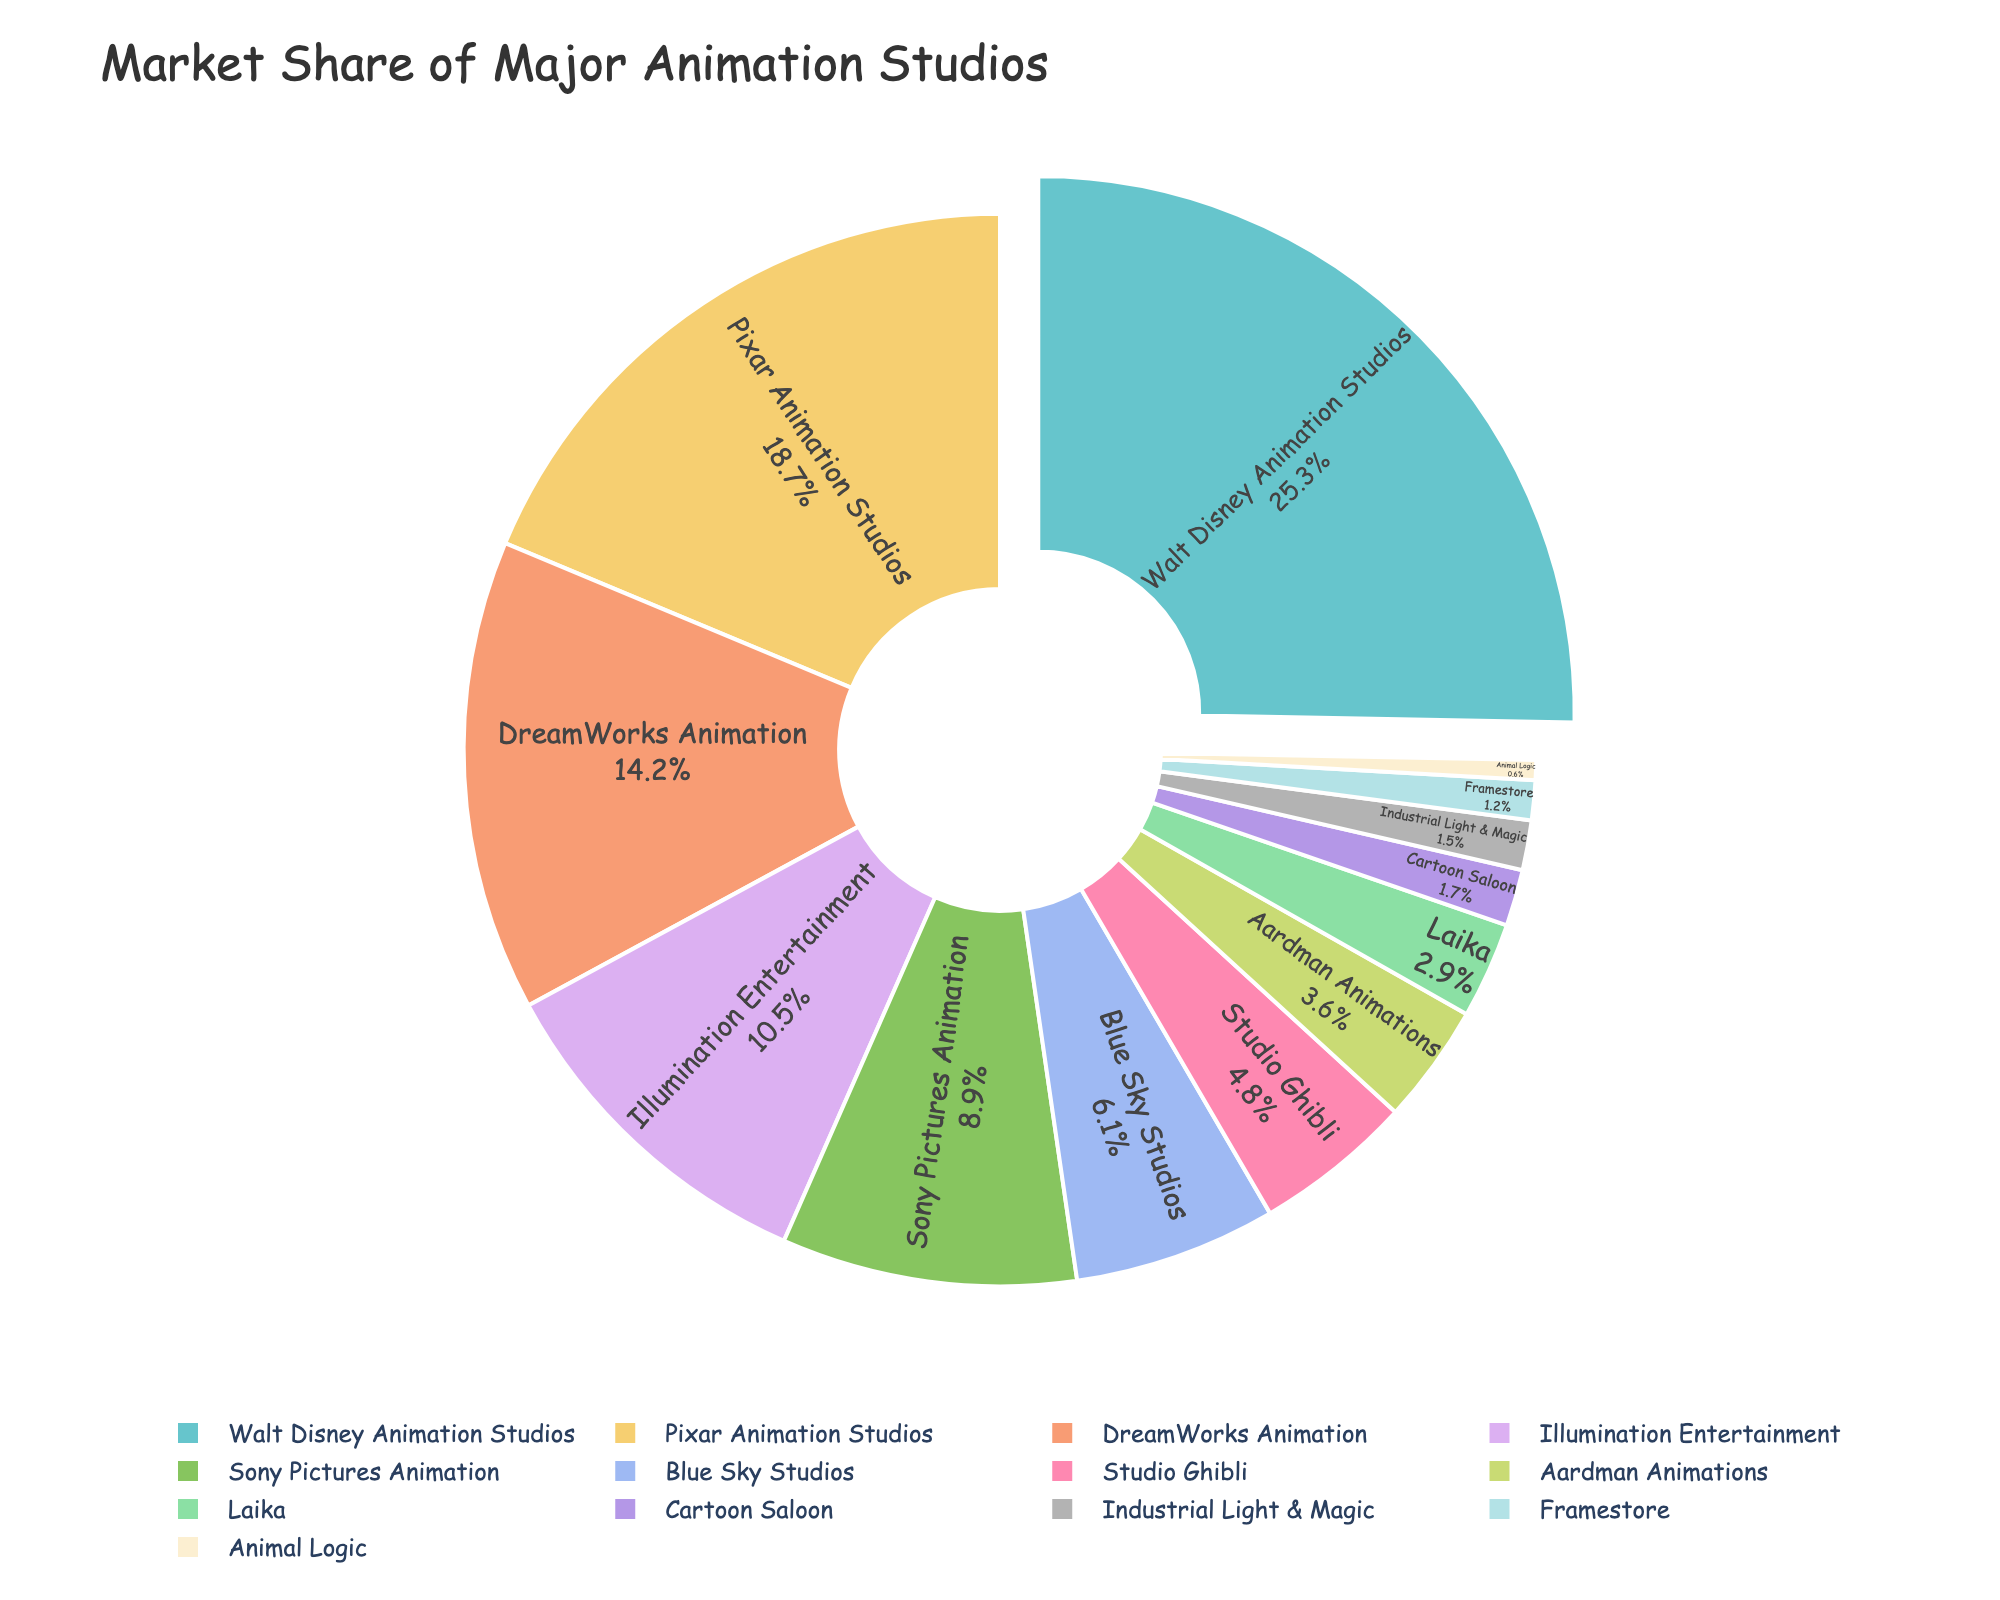What percentage of the market is held by Walt Disney Animation Studios? According to the pie chart, Walt Disney Animation Studios holds 25.3% of the global market share.
Answer: 25.3% What is the combined market share of DreamWorks Animation and Pixar Animation Studios? DreamWorks Animation holds 14.2% and Pixar Animation Studios holds 18.7%. To find the combined market share, add these two values: 14.2% + 18.7% = 32.9%.
Answer: 32.9% Which studio has a larger market share, Sony Pictures Animation or Blue Sky Studios? According to the pie chart, Sony Pictures Animation has 8.9% while Blue Sky Studios has 6.1%. Therefore, Sony Pictures Animation has a larger market share.
Answer: Sony Pictures Animation What is the market share difference between Illumination Entertainment and Studio Ghibli? Illumination Entertainment has a market share of 10.5%, while Studio Ghibli has 4.8%. Subtract the smaller share from the larger share: 10.5% - 4.8% = 5.7%.
Answer: 5.7% Which studio has the smallest market share and what is its value? The pie chart shows that Animal Logic has the smallest market share with 0.6%.
Answer: Animal Logic, 0.6% What is the total market share of the studios with a market share less than 5%? Studios with less than 5% market share are Studio Ghibli (4.8%), Aardman Animations (3.6%), Laika (2.9%), Cartoon Saloon (1.7%), Industrial Light & Magic (1.5%), Framestore (1.2%), and Animal Logic (0.6%). Adding these values: 4.8% + 3.6% + 2.9% + 1.7% + 1.5% + 1.2% + 0.6% = 16.3%.
Answer: 16.3% How many animation studios have a market share greater than or equal to 10%? The studios with a market share greater than or equal to 10% are Walt Disney Animation Studios (25.3%), Pixar Animation Studios (18.7%), and Illumination Entertainment (10.5%). There are three such studios.
Answer: 3 Which studio has the second largest market share and what is its value? According to the pie chart, Pixar Animation Studios has the second largest market share with 18.7%.
Answer: Pixar Animation Studios, 18.7% What's the combined market share of the bottom three studios? The bottom three studios in terms of market share are Framestore (1.2%), Animal Logic (0.6%), and Industrial Light & Magic (1.5%). Adding these values: 1.2% + 0.6% + 1.5% = 3.3%.
Answer: 3.3% 